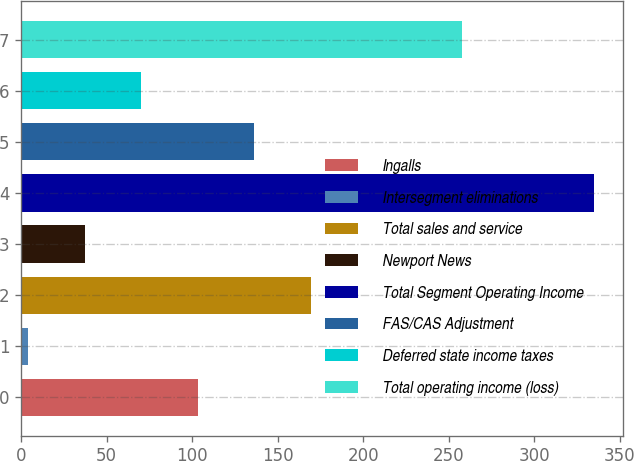<chart> <loc_0><loc_0><loc_500><loc_500><bar_chart><fcel>Ingalls<fcel>Intersegment eliminations<fcel>Total sales and service<fcel>Newport News<fcel>Total Segment Operating Income<fcel>FAS/CAS Adjustment<fcel>Deferred state income taxes<fcel>Total operating income (loss)<nl><fcel>103.3<fcel>4<fcel>169.5<fcel>37.1<fcel>335<fcel>136.4<fcel>70.2<fcel>258<nl></chart> 